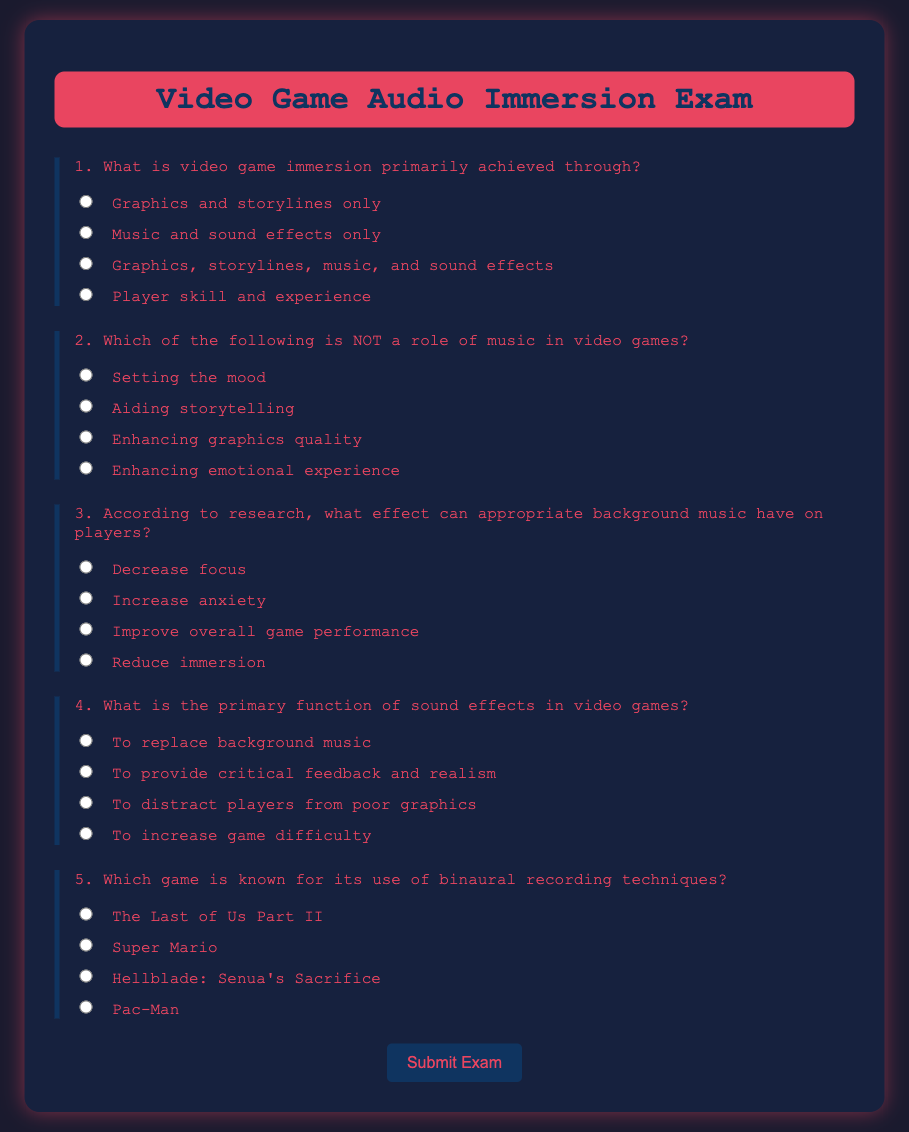What is the title of the exam? The title of the exam is displayed prominently at the top of the document.
Answer: Video Game Audio Immersion Exam What color is the background of the exam container? The background color of the exam container is specified in the style section as a dark shade.
Answer: #16213e Which question asks about the primary function of sound effects? This question is clearly numbered and focuses specifically on sound effects within the exam.
Answer: 4 What is the answer option "c" for the second question? This option is one of the available answers listed under the second question in the document.
Answer: Enhancing graphics quality Which game is associated with binaural recording techniques according to the exam? The exam lists this game as an example in one of its questions.
Answer: Hellblade: Senua's Sacrifice How does the button change when hovered over? The document describes a transition effect that alters its appearance on interaction.
Answer: Changes background color and text color What is the maximum width of the exam container? The document specifies a dimension for the exam's layout.
Answer: 800px 